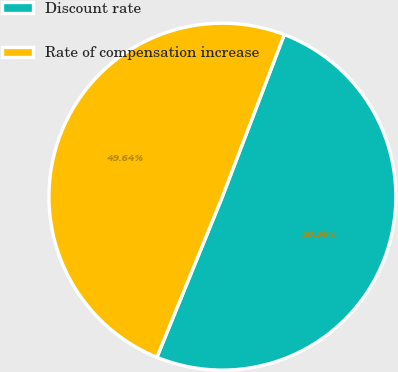<chart> <loc_0><loc_0><loc_500><loc_500><pie_chart><fcel>Discount rate<fcel>Rate of compensation increase<nl><fcel>50.36%<fcel>49.64%<nl></chart> 